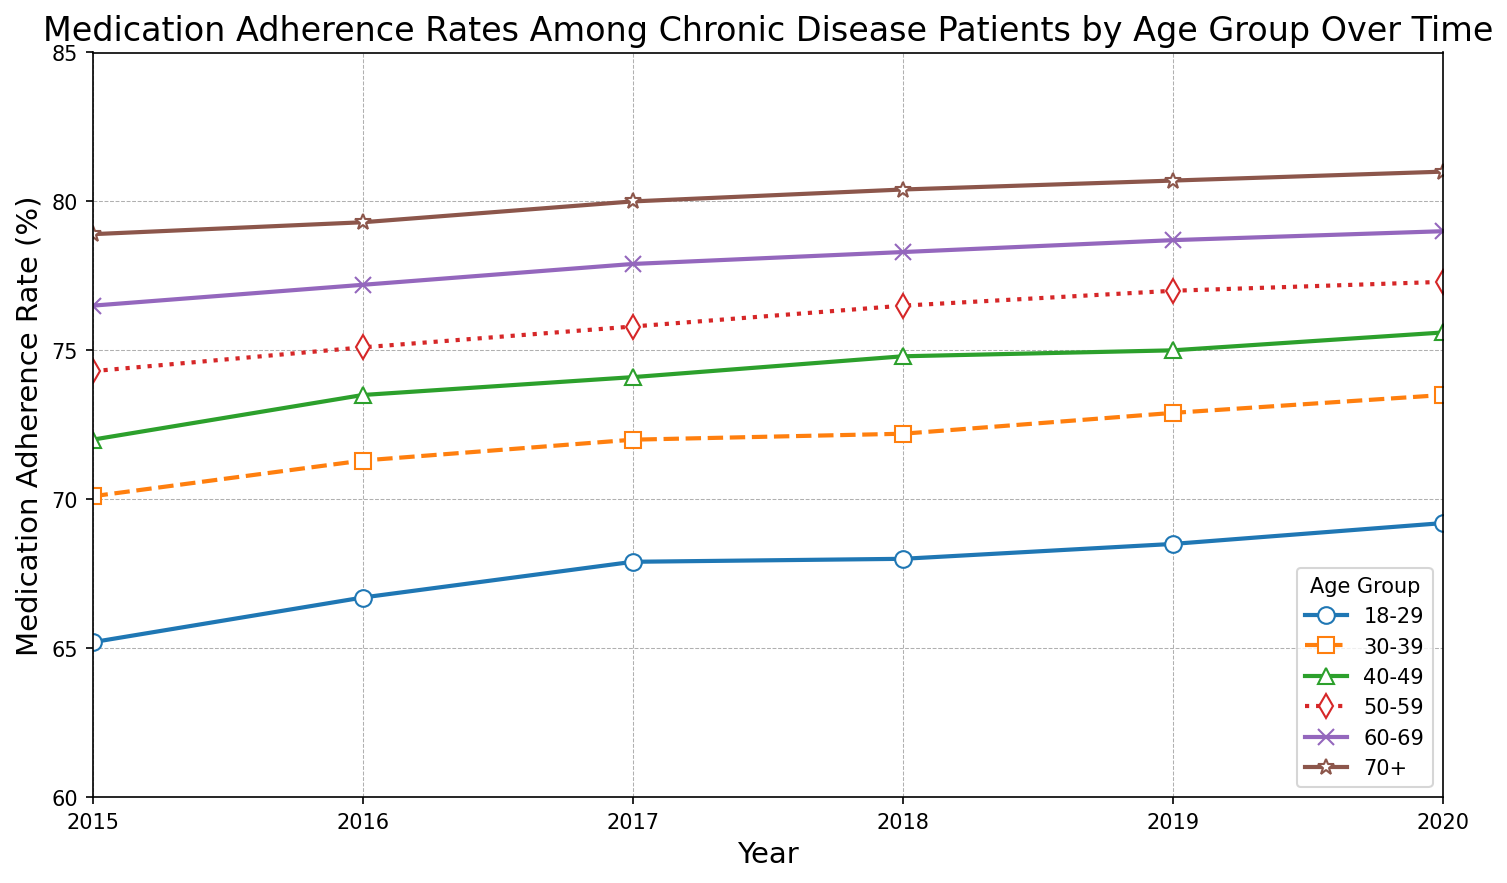what is the medication adherence rate for the 18-29 age group in 2016? Locate the line representing the 18-29 age group, then find the point corresponding to the year 2016 on the x-axis and read the value on the y-axis. The adherence rate is 66.7%.
Answer: 66.7% Which age group had the highest medication adherence rate in 2018? Find the lines for each age group, then look for the values corresponding to the year 2018. The 70+ age group has the highest value on the y-axis, which is 80.4%.
Answer: 70+ By how much did the medication adherence rate for the 50-59 age group increase from 2015 to 2020? Find the points for 2015 and 2020 for the 50-59 age group on the graph. The rates are 74.3% and 77.3%, respectively. Subtract the 2015 rate from the 2020 rate: 77.3% - 74.3% = 3.0%.
Answer: 3.0% Which age group had the lowest increase in medication adherence rate from 2015 to 2020? Calculate the difference for each age group from 2015 to 2020. The smallest increase is for the 18-29 age group: 69.2% - 65.2% = 4.0%. Compare this to other groups.
Answer: 18-29 What is the trend of the medication adherence rate across all age groups over time? Observe the pattern of the lines for all age groups from 2015 to 2020. Each line generally trends upward, indicating an overall increase in adherence rates over time.
Answer: Increasing Which age group has the most consistent increase in their medication adherence rate from 2015 to 2020? Check lines for steady, equal increments. The 70+ age group line shows the most consistent yearly increase.
Answer: 70+ Which two age groups had a similar adherence rate in 2015, and what were their values? Find the adherence rates for each age group in 2015, then find the two groups with the closest values. The 50-59 and 60-69 age groups have similar rates at 74.3% and 76.5%.
Answer: 50-59: 74.3%, 60-69: 76.5% What was the average medication adherence rate for the 30-39 age group across the years 2015-2020? Add the adherence rates for each year for the 30-39 age group and divide by 6: (70.1 + 71.3 + 72.0 + 72.2 + 72.9 + 73.5) / 6 = (432) / 6 = 72.0%
Answer: 72.0% By how much did the medication adherence rate for the 40-49 age group increase from 2016 to 2018? Find the adherence rates for 2016 and 2018 for the 40-49 age group: 73.5% and 74.8%. Subtract the 2016 value from the 2018 value: 74.8% - 73.5% = 1.3%.
Answer: 1.3% Comparing 2017 and 2018, which age group had the smallest change in medication adherence rate? Find the rate changes for each age group from 2017 to 2018 and identify the smallest. The 18-29 age group has the smallest change: 68.0% - 67.9% = 0.1%.
Answer: 18-29 